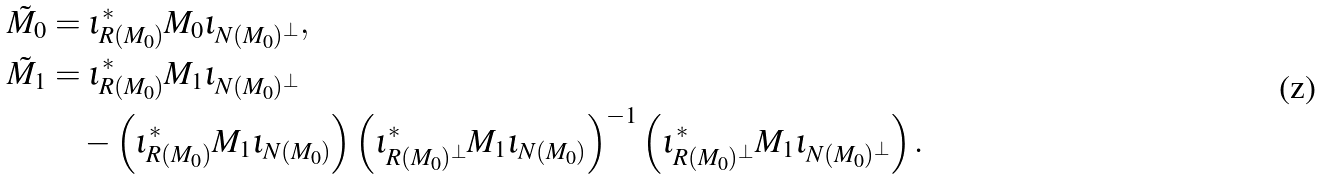Convert formula to latex. <formula><loc_0><loc_0><loc_500><loc_500>\tilde { M } _ { 0 } & = \iota _ { R ( M _ { 0 } ) } ^ { \ast } M _ { 0 } \iota _ { N ( M _ { 0 } ) ^ { \bot } } , \\ \tilde { M } _ { 1 } & = \iota _ { R ( M _ { 0 } ) } ^ { \ast } M _ { 1 } \iota _ { N ( M _ { 0 } ) ^ { \bot } } \\ & \quad - \left ( \iota _ { R ( M _ { 0 } ) } ^ { \ast } M _ { 1 } \iota _ { N ( M _ { 0 } ) } \right ) \left ( \iota _ { R ( M _ { 0 } ) ^ { \bot } } ^ { \ast } M _ { 1 } \iota _ { N ( M _ { 0 } ) } \right ) ^ { - 1 } \left ( \iota _ { R ( M _ { 0 } ) ^ { \bot } } ^ { \ast } M _ { 1 } \iota _ { N ( M _ { 0 } ) ^ { \bot } } \right ) .</formula> 